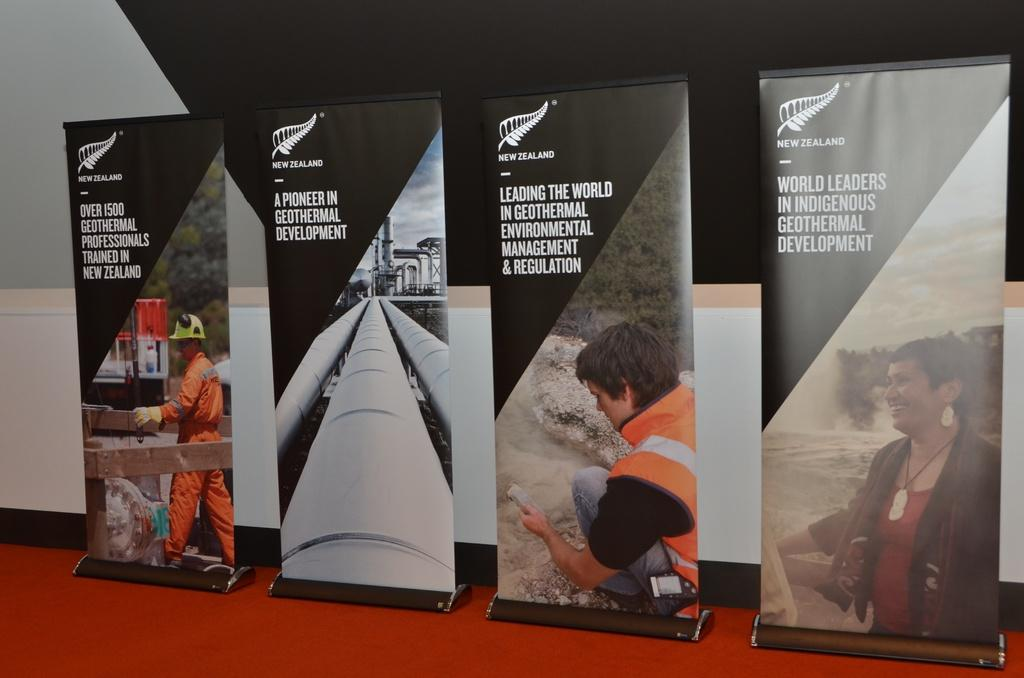Provide a one-sentence caption for the provided image. Four signs with information about the New Zealand scientists. 